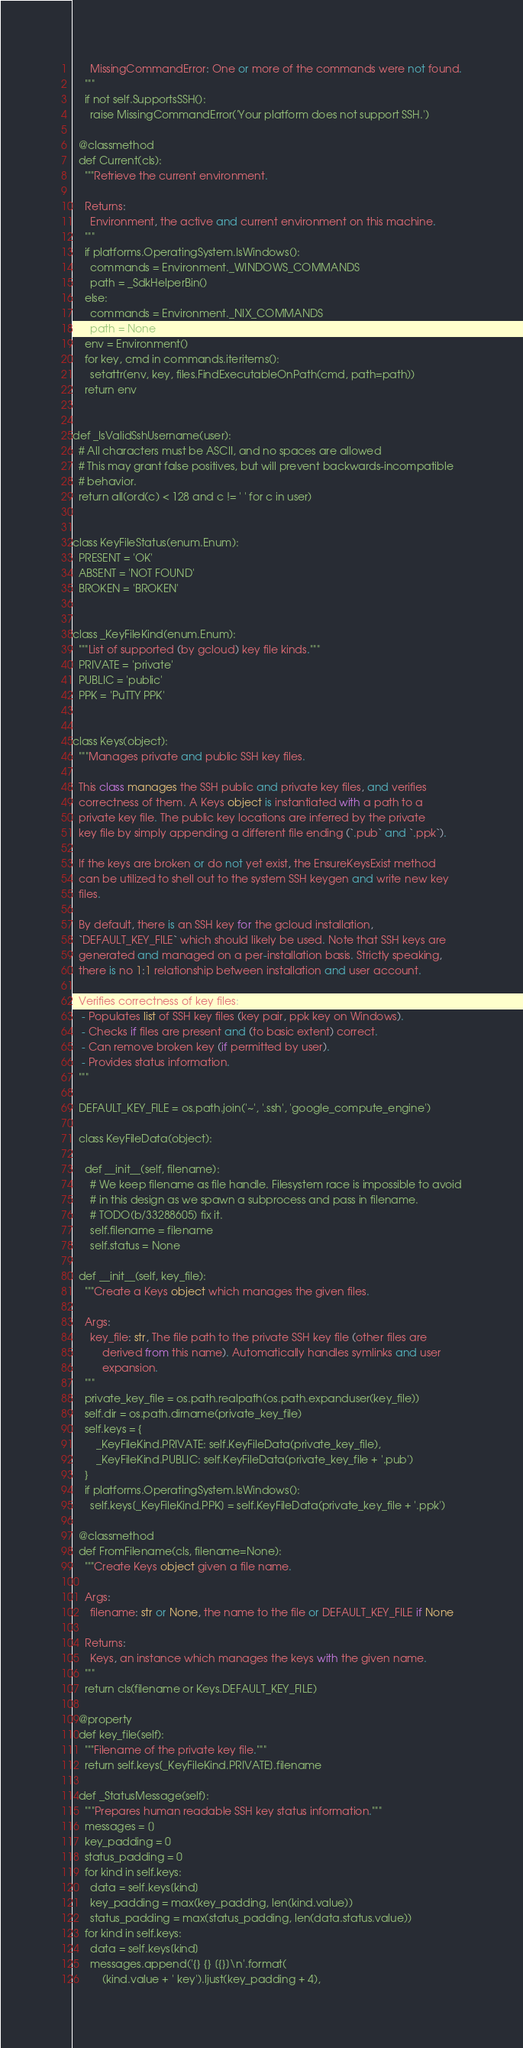Convert code to text. <code><loc_0><loc_0><loc_500><loc_500><_Python_>      MissingCommandError: One or more of the commands were not found.
    """
    if not self.SupportsSSH():
      raise MissingCommandError('Your platform does not support SSH.')

  @classmethod
  def Current(cls):
    """Retrieve the current environment.

    Returns:
      Environment, the active and current environment on this machine.
    """
    if platforms.OperatingSystem.IsWindows():
      commands = Environment._WINDOWS_COMMANDS
      path = _SdkHelperBin()
    else:
      commands = Environment._NIX_COMMANDS
      path = None
    env = Environment()
    for key, cmd in commands.iteritems():
      setattr(env, key, files.FindExecutableOnPath(cmd, path=path))
    return env


def _IsValidSshUsername(user):
  # All characters must be ASCII, and no spaces are allowed
  # This may grant false positives, but will prevent backwards-incompatible
  # behavior.
  return all(ord(c) < 128 and c != ' ' for c in user)


class KeyFileStatus(enum.Enum):
  PRESENT = 'OK'
  ABSENT = 'NOT FOUND'
  BROKEN = 'BROKEN'


class _KeyFileKind(enum.Enum):
  """List of supported (by gcloud) key file kinds."""
  PRIVATE = 'private'
  PUBLIC = 'public'
  PPK = 'PuTTY PPK'


class Keys(object):
  """Manages private and public SSH key files.

  This class manages the SSH public and private key files, and verifies
  correctness of them. A Keys object is instantiated with a path to a
  private key file. The public key locations are inferred by the private
  key file by simply appending a different file ending (`.pub` and `.ppk`).

  If the keys are broken or do not yet exist, the EnsureKeysExist method
  can be utilized to shell out to the system SSH keygen and write new key
  files.

  By default, there is an SSH key for the gcloud installation,
  `DEFAULT_KEY_FILE` which should likely be used. Note that SSH keys are
  generated and managed on a per-installation basis. Strictly speaking,
  there is no 1:1 relationship between installation and user account.

  Verifies correctness of key files:
   - Populates list of SSH key files (key pair, ppk key on Windows).
   - Checks if files are present and (to basic extent) correct.
   - Can remove broken key (if permitted by user).
   - Provides status information.
  """

  DEFAULT_KEY_FILE = os.path.join('~', '.ssh', 'google_compute_engine')

  class KeyFileData(object):

    def __init__(self, filename):
      # We keep filename as file handle. Filesystem race is impossible to avoid
      # in this design as we spawn a subprocess and pass in filename.
      # TODO(b/33288605) fix it.
      self.filename = filename
      self.status = None

  def __init__(self, key_file):
    """Create a Keys object which manages the given files.

    Args:
      key_file: str, The file path to the private SSH key file (other files are
          derived from this name). Automatically handles symlinks and user
          expansion.
    """
    private_key_file = os.path.realpath(os.path.expanduser(key_file))
    self.dir = os.path.dirname(private_key_file)
    self.keys = {
        _KeyFileKind.PRIVATE: self.KeyFileData(private_key_file),
        _KeyFileKind.PUBLIC: self.KeyFileData(private_key_file + '.pub')
    }
    if platforms.OperatingSystem.IsWindows():
      self.keys[_KeyFileKind.PPK] = self.KeyFileData(private_key_file + '.ppk')

  @classmethod
  def FromFilename(cls, filename=None):
    """Create Keys object given a file name.

    Args:
      filename: str or None, the name to the file or DEFAULT_KEY_FILE if None

    Returns:
      Keys, an instance which manages the keys with the given name.
    """
    return cls(filename or Keys.DEFAULT_KEY_FILE)

  @property
  def key_file(self):
    """Filename of the private key file."""
    return self.keys[_KeyFileKind.PRIVATE].filename

  def _StatusMessage(self):
    """Prepares human readable SSH key status information."""
    messages = []
    key_padding = 0
    status_padding = 0
    for kind in self.keys:
      data = self.keys[kind]
      key_padding = max(key_padding, len(kind.value))
      status_padding = max(status_padding, len(data.status.value))
    for kind in self.keys:
      data = self.keys[kind]
      messages.append('{} {} [{}]\n'.format(
          (kind.value + ' key').ljust(key_padding + 4),</code> 